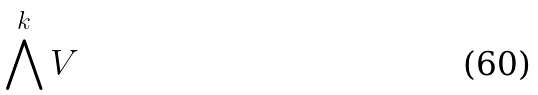Convert formula to latex. <formula><loc_0><loc_0><loc_500><loc_500>\bigwedge ^ { k } V</formula> 